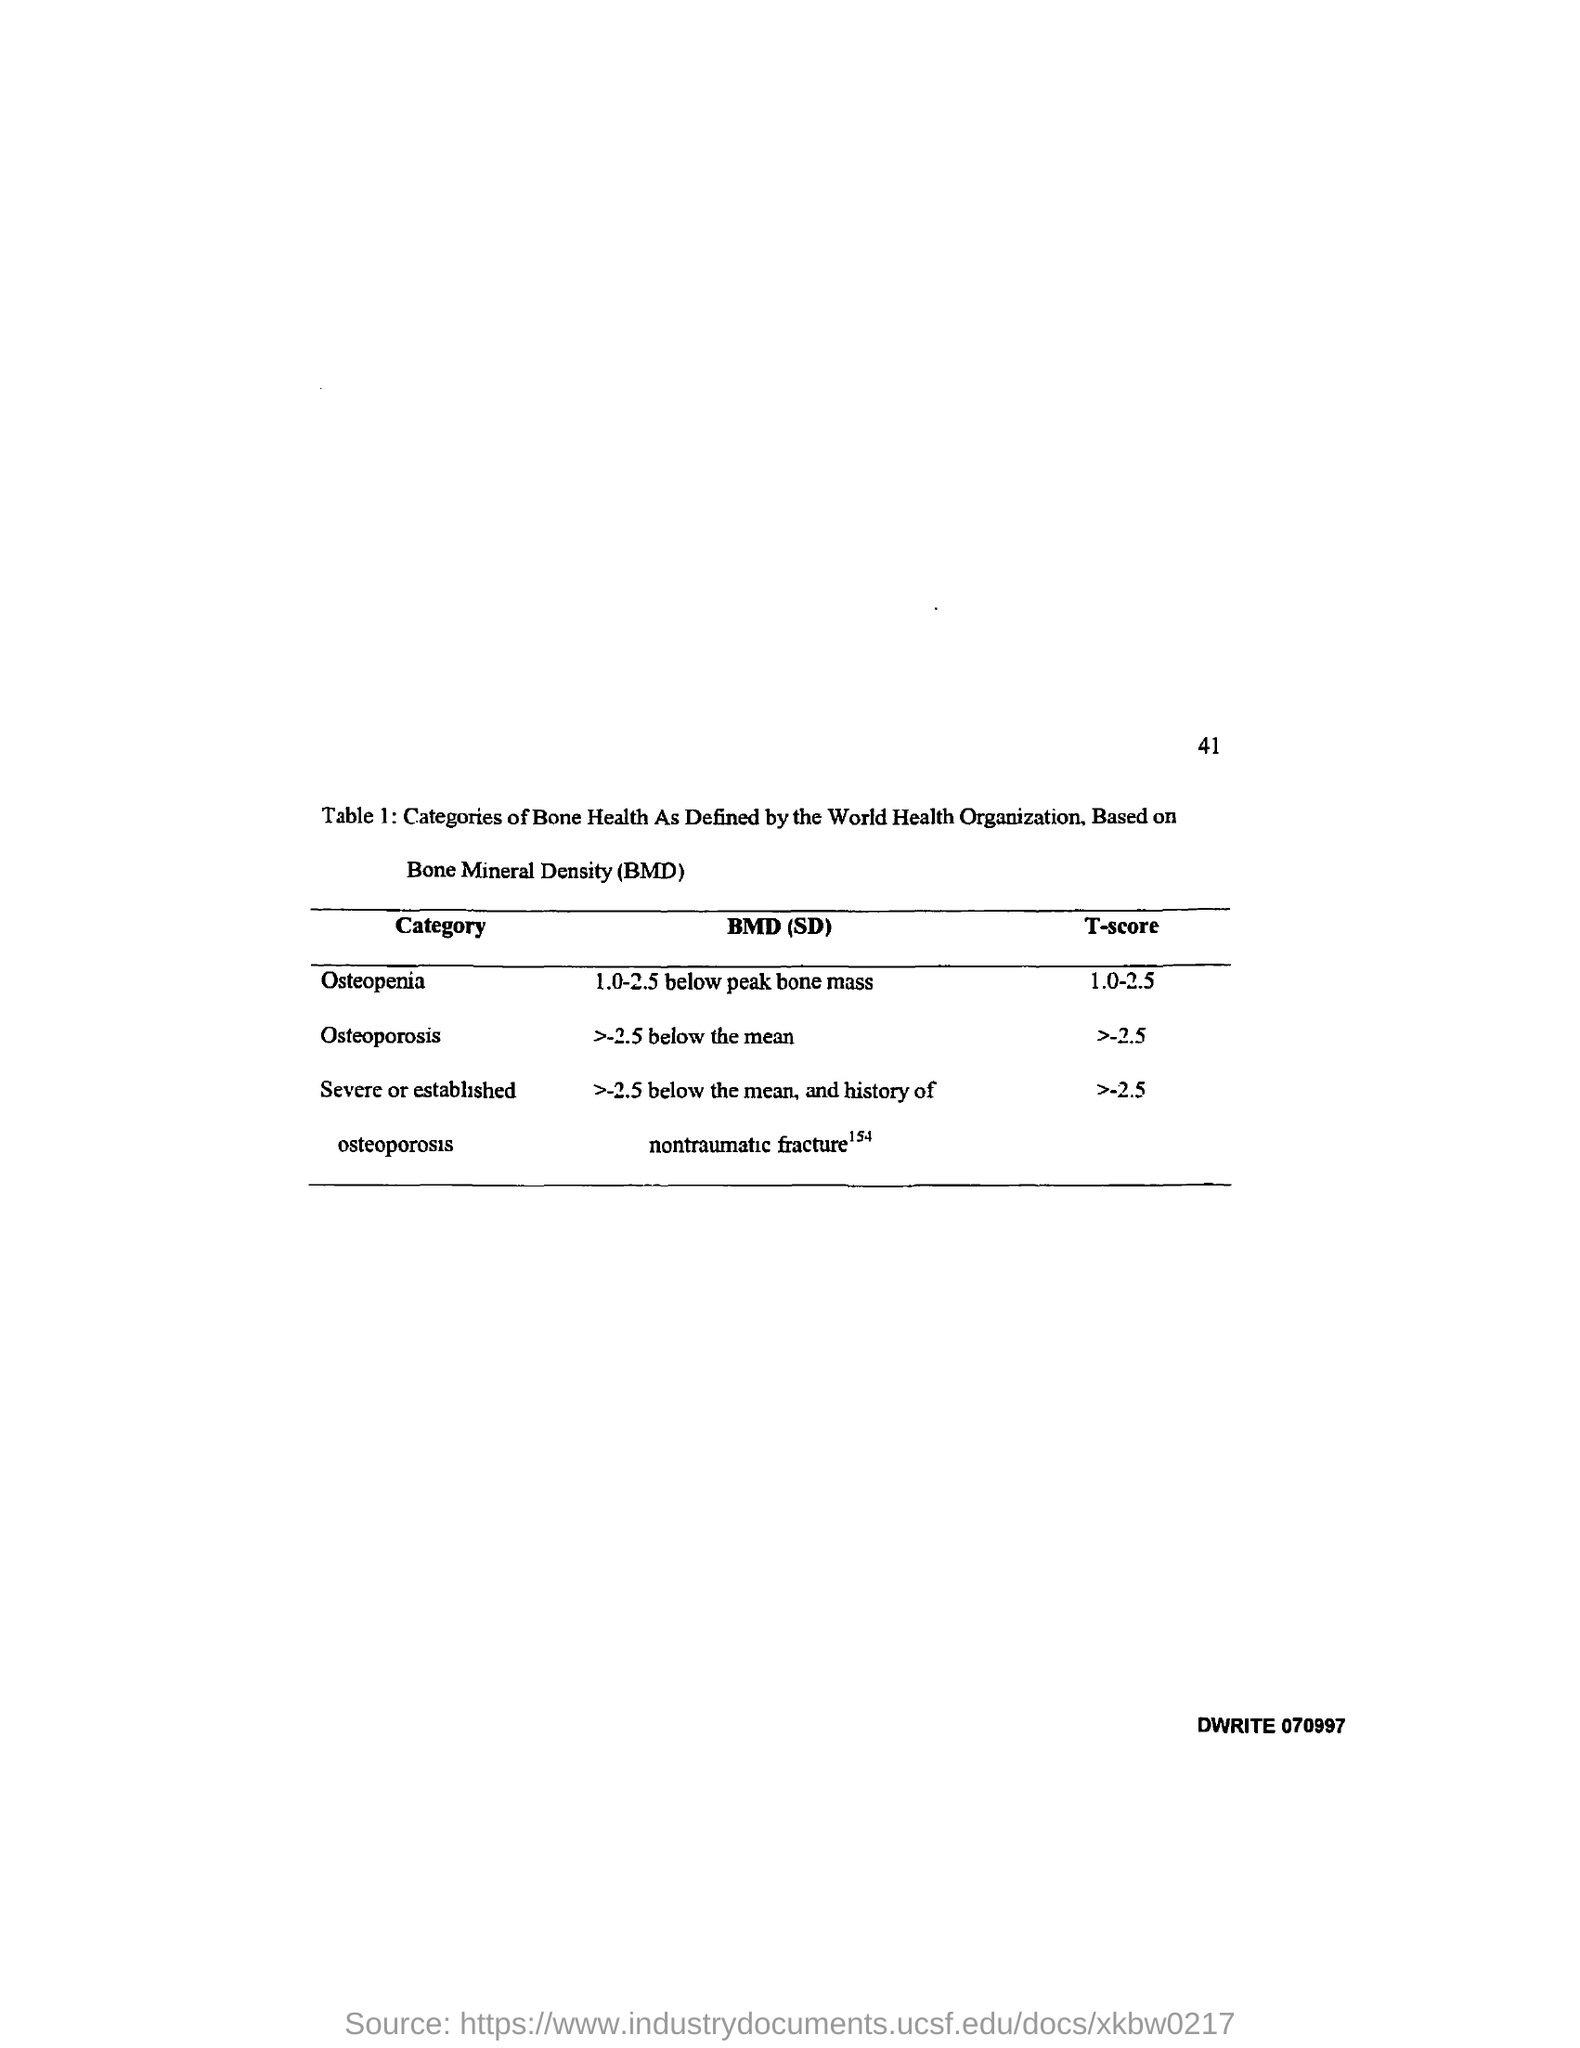Outline some significant characteristics in this image. BMD stands for bone mineral density, a measure of the amount of minerals such as calcium and phosphorus in bones. The T-score for severe or established osteoporosis is greater than or equal to -2.5. The BMD (standard deviation) for osteopenia is defined as 1.0-2.5 below peak bone mass. The T-score for osteopenia is a value between 1.0 and 2.5. The T-score for osteoporosis is greater than or equal to -2.5. 